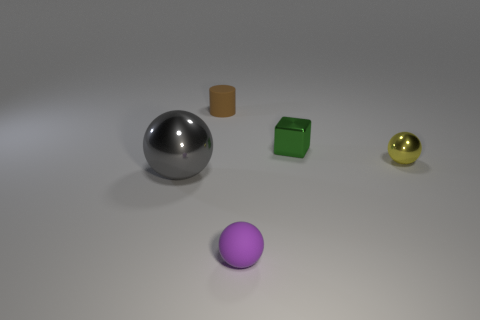Subtract all tiny spheres. How many spheres are left? 1 Add 3 small metal things. How many objects exist? 8 Subtract all cylinders. How many objects are left? 4 Add 1 metal balls. How many metal balls are left? 3 Add 2 small gray rubber balls. How many small gray rubber balls exist? 2 Subtract 0 cyan cylinders. How many objects are left? 5 Subtract all tiny metallic things. Subtract all tiny matte objects. How many objects are left? 1 